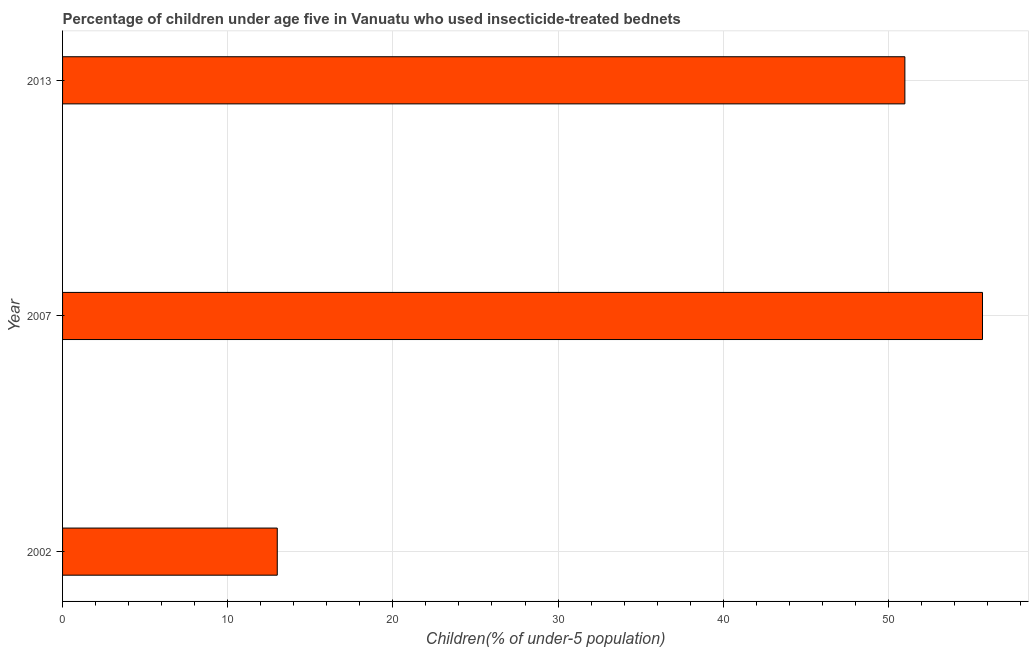Does the graph contain any zero values?
Your answer should be very brief. No. What is the title of the graph?
Provide a succinct answer. Percentage of children under age five in Vanuatu who used insecticide-treated bednets. What is the label or title of the X-axis?
Provide a short and direct response. Children(% of under-5 population). Across all years, what is the maximum percentage of children who use of insecticide-treated bed nets?
Ensure brevity in your answer.  55.7. In which year was the percentage of children who use of insecticide-treated bed nets maximum?
Provide a short and direct response. 2007. What is the sum of the percentage of children who use of insecticide-treated bed nets?
Provide a short and direct response. 119.7. What is the average percentage of children who use of insecticide-treated bed nets per year?
Make the answer very short. 39.9. What is the ratio of the percentage of children who use of insecticide-treated bed nets in 2002 to that in 2007?
Keep it short and to the point. 0.23. Is the percentage of children who use of insecticide-treated bed nets in 2007 less than that in 2013?
Ensure brevity in your answer.  No. Is the difference between the percentage of children who use of insecticide-treated bed nets in 2007 and 2013 greater than the difference between any two years?
Your response must be concise. No. Is the sum of the percentage of children who use of insecticide-treated bed nets in 2002 and 2007 greater than the maximum percentage of children who use of insecticide-treated bed nets across all years?
Keep it short and to the point. Yes. What is the difference between the highest and the lowest percentage of children who use of insecticide-treated bed nets?
Make the answer very short. 42.7. How many bars are there?
Ensure brevity in your answer.  3. Are all the bars in the graph horizontal?
Offer a very short reply. Yes. What is the difference between two consecutive major ticks on the X-axis?
Your answer should be very brief. 10. Are the values on the major ticks of X-axis written in scientific E-notation?
Offer a very short reply. No. What is the Children(% of under-5 population) in 2002?
Provide a short and direct response. 13. What is the Children(% of under-5 population) of 2007?
Ensure brevity in your answer.  55.7. What is the Children(% of under-5 population) in 2013?
Make the answer very short. 51. What is the difference between the Children(% of under-5 population) in 2002 and 2007?
Make the answer very short. -42.7. What is the difference between the Children(% of under-5 population) in 2002 and 2013?
Provide a short and direct response. -38. What is the difference between the Children(% of under-5 population) in 2007 and 2013?
Your answer should be very brief. 4.7. What is the ratio of the Children(% of under-5 population) in 2002 to that in 2007?
Your answer should be very brief. 0.23. What is the ratio of the Children(% of under-5 population) in 2002 to that in 2013?
Your answer should be very brief. 0.26. What is the ratio of the Children(% of under-5 population) in 2007 to that in 2013?
Your answer should be compact. 1.09. 